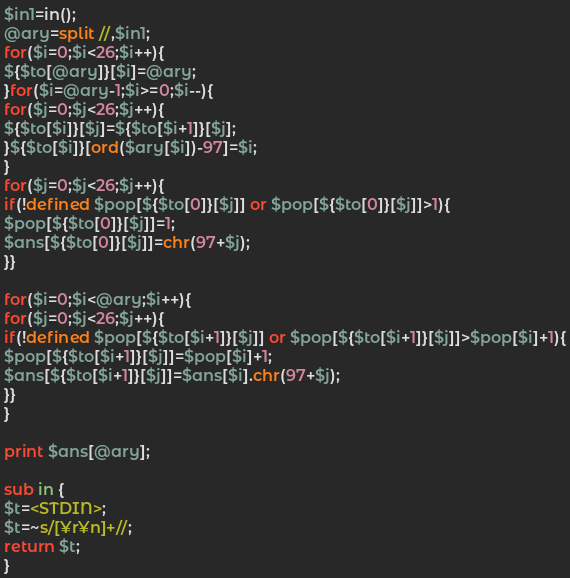<code> <loc_0><loc_0><loc_500><loc_500><_Perl_>$in1=in();
@ary=split //,$in1;
for($i=0;$i<26;$i++){
${$to[@ary]}[$i]=@ary;
}for($i=@ary-1;$i>=0;$i--){
for($j=0;$j<26;$j++){
${$to[$i]}[$j]=${$to[$i+1]}[$j];
}${$to[$i]}[ord($ary[$i])-97]=$i;
}
for($j=0;$j<26;$j++){
if(!defined $pop[${$to[0]}[$j]] or $pop[${$to[0]}[$j]]>1){
$pop[${$to[0]}[$j]]=1;
$ans[${$to[0]}[$j]]=chr(97+$j);
}}

for($i=0;$i<@ary;$i++){
for($j=0;$j<26;$j++){
if(!defined $pop[${$to[$i+1]}[$j]] or $pop[${$to[$i+1]}[$j]]>$pop[$i]+1){
$pop[${$to[$i+1]}[$j]]=$pop[$i]+1;
$ans[${$to[$i+1]}[$j]]=$ans[$i].chr(97+$j);
}}
}

print $ans[@ary];

sub in {
$t=<STDIN>;
$t=~s/[¥r¥n]+//;
return $t;
}
</code> 